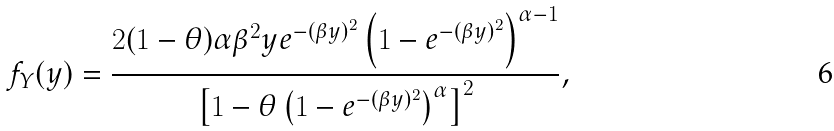Convert formula to latex. <formula><loc_0><loc_0><loc_500><loc_500>f _ { Y } ( y ) = \frac { 2 ( 1 - \theta ) \alpha \beta ^ { 2 } y e ^ { - ( \beta y ) ^ { 2 } } \left ( 1 - e ^ { - ( \beta y ) ^ { 2 } } \right ) ^ { \alpha - 1 } } { \left [ 1 - \theta \left ( 1 - e ^ { - ( \beta y ) ^ { 2 } } \right ) ^ { \alpha } \right ] ^ { 2 } } ,</formula> 